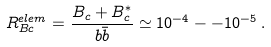Convert formula to latex. <formula><loc_0><loc_0><loc_500><loc_500>R _ { B c } ^ { e l e m } = \frac { B _ { c } + B _ { c } ^ { * } } { b \bar { b } } \simeq 1 0 ^ { - 4 } - - 1 0 ^ { - 5 } \, .</formula> 